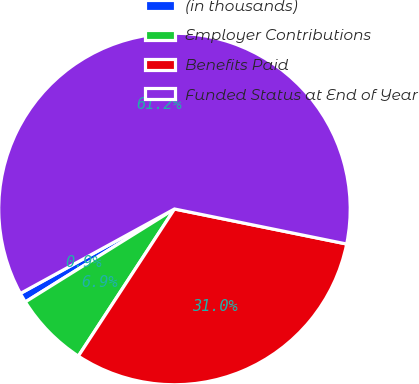Convert chart. <chart><loc_0><loc_0><loc_500><loc_500><pie_chart><fcel>(in thousands)<fcel>Employer Contributions<fcel>Benefits Paid<fcel>Funded Status at End of Year<nl><fcel>0.89%<fcel>6.92%<fcel>31.02%<fcel>61.18%<nl></chart> 